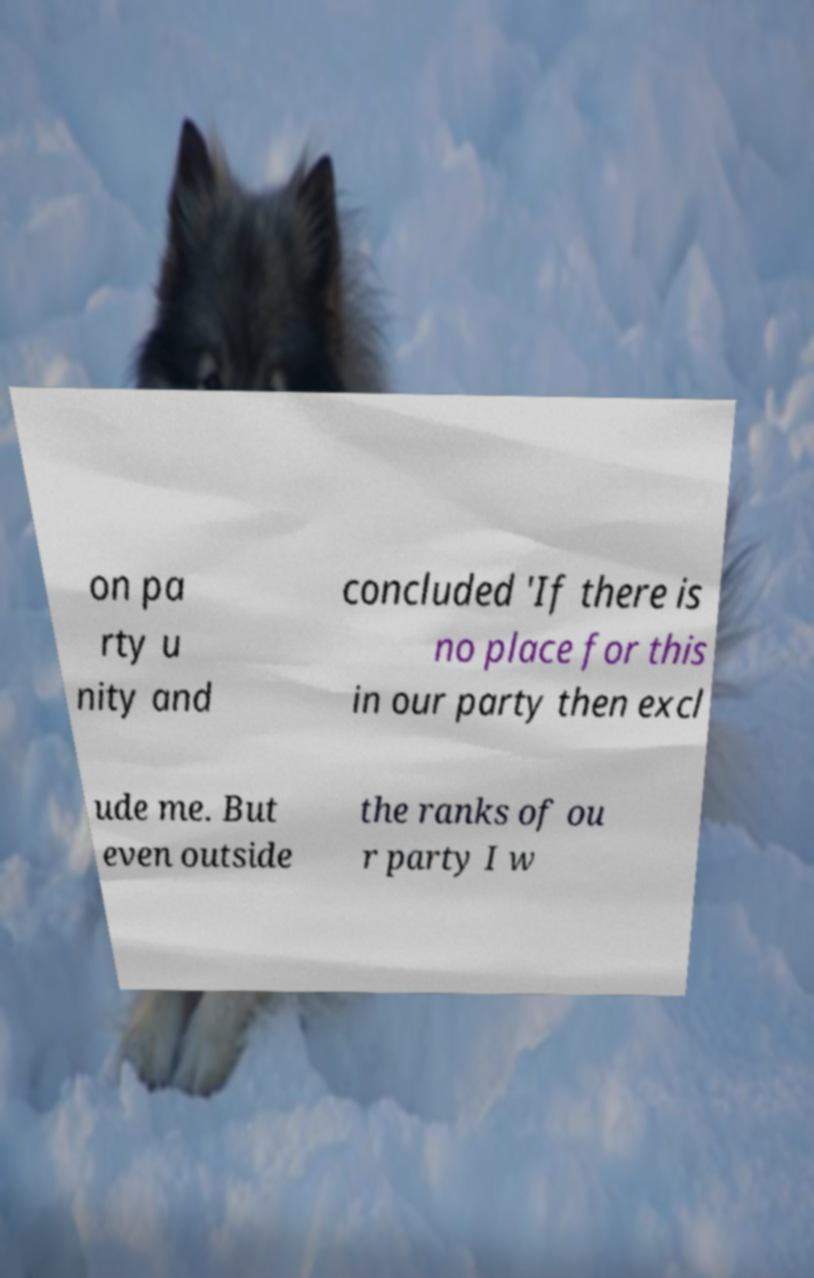What messages or text are displayed in this image? I need them in a readable, typed format. on pa rty u nity and concluded 'If there is no place for this in our party then excl ude me. But even outside the ranks of ou r party I w 